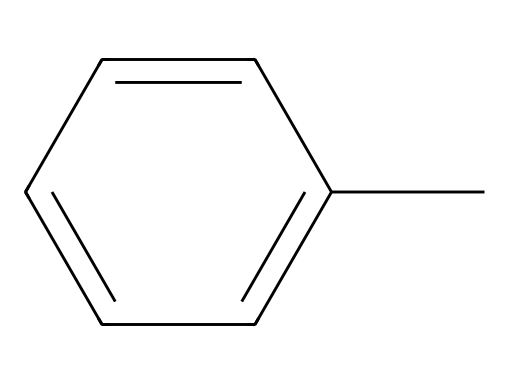What is the name of this compound? The SMILES representation shows the structure contains a methyl group attached to a phenyl ring, which identifies it as toluene.
Answer: toluene How many carbon atoms are in toluene? Analyzing the SMILES representation, the compound has a total of 7 carbon atoms: 6 from the phenyl ring and 1 from the methyl group.
Answer: 7 What is the molecular formula of toluene? The presence of 7 carbon atoms and 8 hydrogen atoms, as derived from the structure, gives us the molecular formula C7H8.
Answer: C7H8 What type of chemical structure does toluene have? The structure features a benzene ring from the phenyl part and a methyl group, which classifies it as an aromatic compound due to its delocalized electrons in the ring.
Answer: aromatic What characteristic of toluene contributes to its use as a solvent? Toluene is non-polar and can dissolve many non-polar and some polar substances, which makes it an effective solvent in oil-based paints.
Answer: non-polar How many hydrogen atoms are bonded to the carbon chain in toluene? In the toluene structure, the methyl group contributes 3 hydrogen atoms, and the phenyl ring contributes 5, totaling 8 hydrogen atoms connected to carbons.
Answer: 8 Does toluene exhibit resonance? Yes, the aromatic ring structure allows for resonance stabilization by having delocalized electrons across the carbon atoms in the ring, a key feature of aromatic compounds.
Answer: yes 